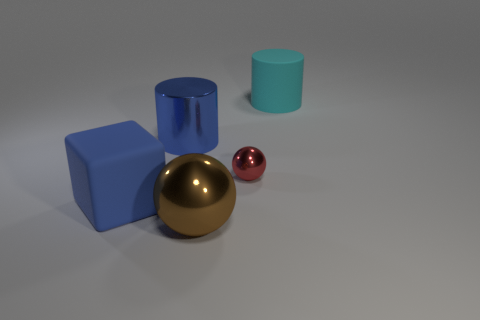There is a rubber thing on the right side of the cube; does it have the same shape as the big metal thing behind the blue block?
Make the answer very short. Yes. What shape is the thing that is in front of the tiny object and on the right side of the blue shiny object?
Ensure brevity in your answer.  Sphere. There is another ball that is the same material as the big ball; what is its size?
Make the answer very short. Small. Is the number of yellow matte things less than the number of red metallic spheres?
Your answer should be compact. Yes. What is the material of the cylinder that is right of the shiny ball behind the matte object on the left side of the big blue cylinder?
Provide a short and direct response. Rubber. Do the sphere behind the large matte cube and the large object right of the small red shiny ball have the same material?
Offer a very short reply. No. What is the size of the thing that is right of the big blue cube and left of the brown metal thing?
Provide a succinct answer. Large. What is the material of the brown sphere that is the same size as the cyan thing?
Your answer should be very brief. Metal. What number of small red metallic spheres are in front of the rubber object that is behind the big blue object right of the big blue cube?
Your answer should be compact. 1. There is a metallic object that is behind the red object; does it have the same color as the object left of the large shiny cylinder?
Your response must be concise. Yes. 